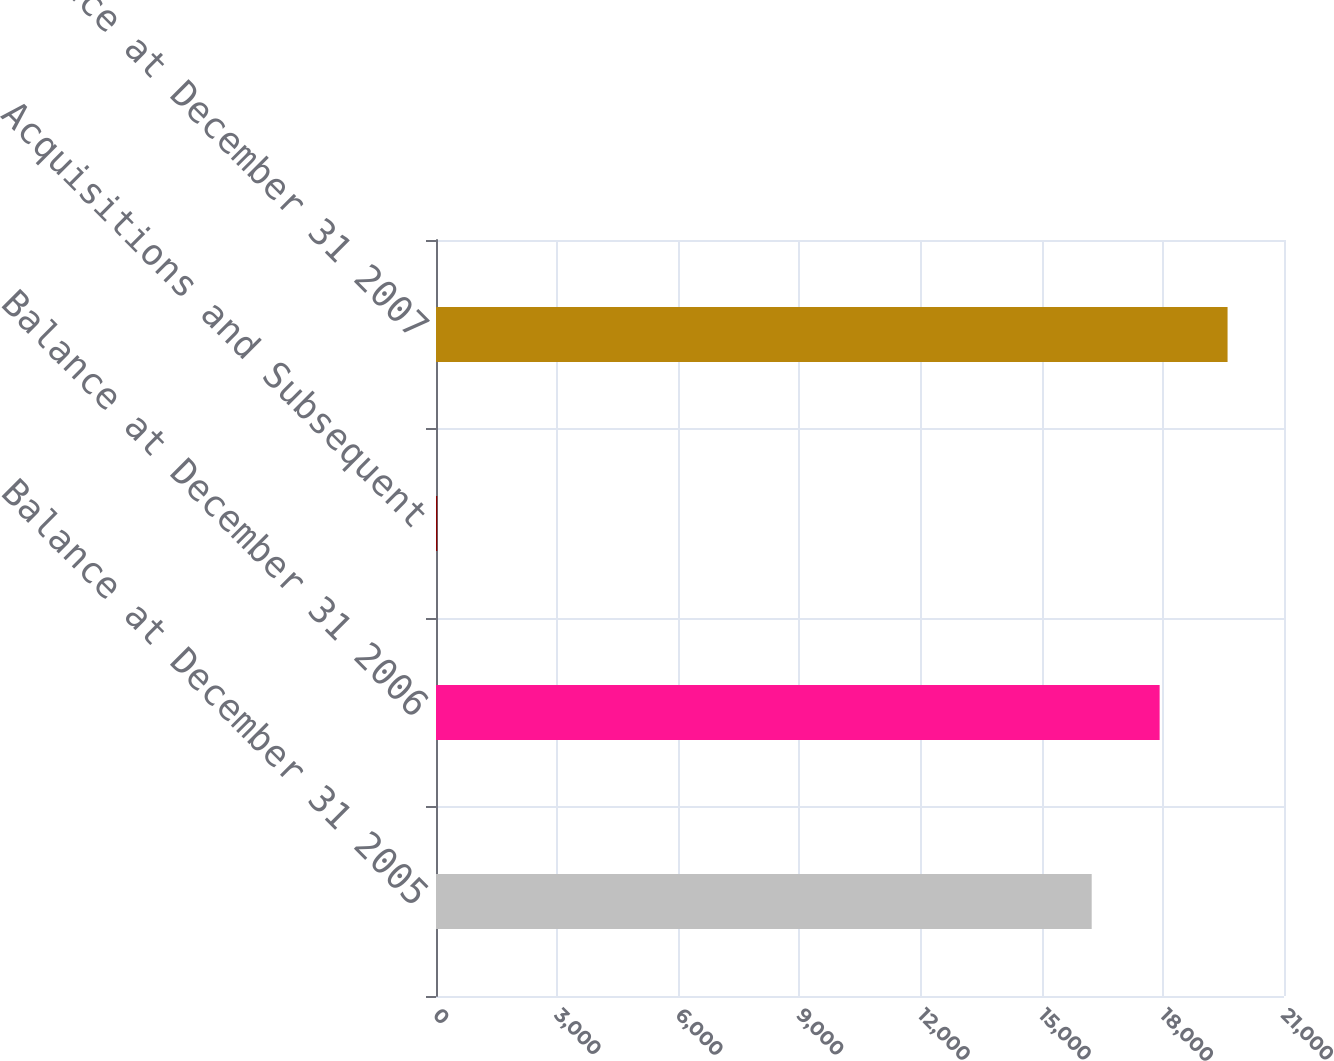Convert chart to OTSL. <chart><loc_0><loc_0><loc_500><loc_500><bar_chart><fcel>Balance at December 31 2005<fcel>Balance at December 31 2006<fcel>Acquisitions and Subsequent<fcel>Balance at December 31 2007<nl><fcel>16238<fcel>17920.2<fcel>32<fcel>19602.4<nl></chart> 